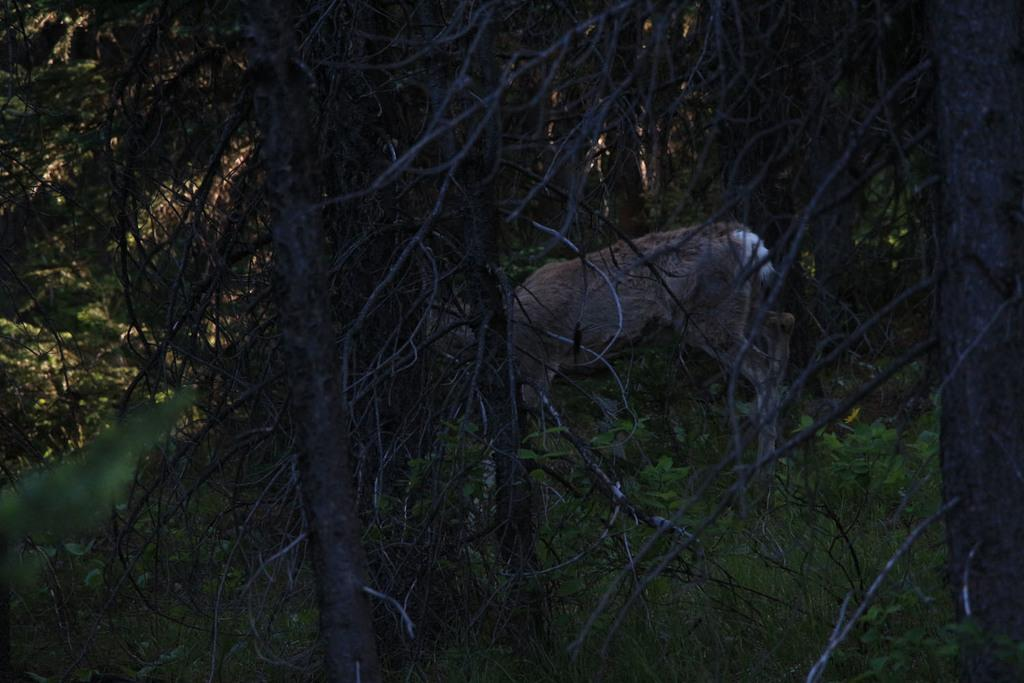What is the overall lighting condition in the image? The image is dark. What type of living creature can be seen in the image? There is an animal in the image. What natural elements are present in the image? There are branches and green leaves in the image. What type of jeans is the animal wearing in the image? There are no jeans present in the image, as animals do not wear clothing. 